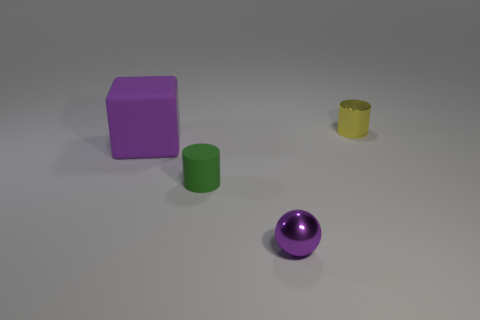How many objects are either purple objects right of the big purple rubber thing or purple things in front of the green matte thing? In the image, there is one large purple object on the left, which is a cube, and one smaller purple object on the right, which is a sphere. There are no purple objects directly to the right of the large purple cube, nor are there any purple objects in front of the green cylindrical object. Thus, according to your specific criteria, the count of such objects is zero. 